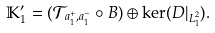<formula> <loc_0><loc_0><loc_500><loc_500>\mathbb { K } ^ { \prime } _ { 1 } = ( \mathcal { T } _ { a _ { 1 } ^ { + } , a _ { 1 } ^ { - } } \circ B ) \oplus \ker ( D | _ { L ^ { 2 } _ { 1 } } ) .</formula> 